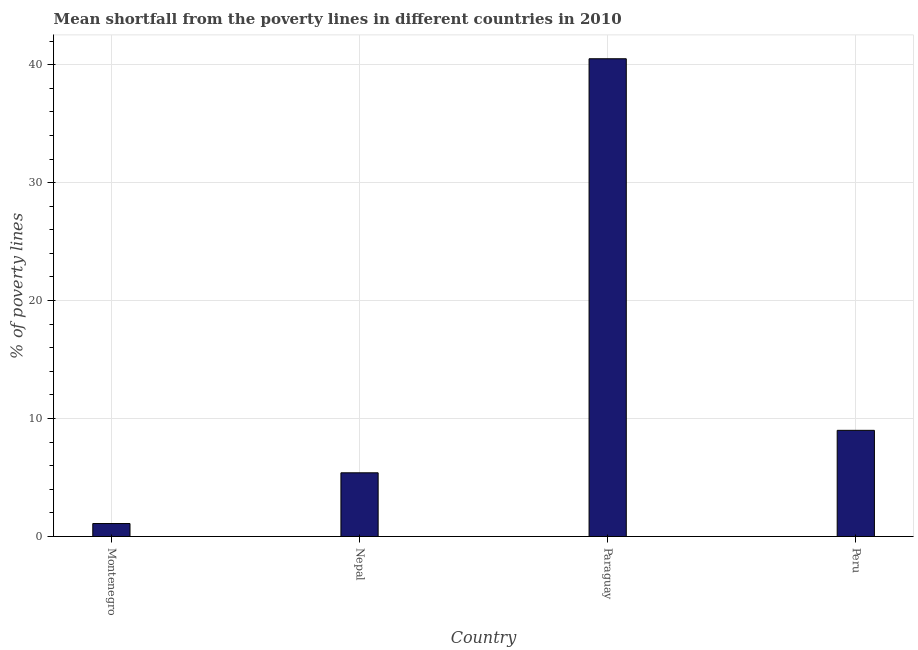Does the graph contain any zero values?
Your answer should be very brief. No. What is the title of the graph?
Make the answer very short. Mean shortfall from the poverty lines in different countries in 2010. What is the label or title of the X-axis?
Your response must be concise. Country. What is the label or title of the Y-axis?
Provide a short and direct response. % of poverty lines. Across all countries, what is the maximum poverty gap at national poverty lines?
Give a very brief answer. 40.5. In which country was the poverty gap at national poverty lines maximum?
Your answer should be very brief. Paraguay. In which country was the poverty gap at national poverty lines minimum?
Your answer should be compact. Montenegro. What is the sum of the poverty gap at national poverty lines?
Your answer should be very brief. 56. What is the difference between the poverty gap at national poverty lines in Paraguay and Peru?
Your answer should be very brief. 31.5. What is the average poverty gap at national poverty lines per country?
Offer a terse response. 14. What is the median poverty gap at national poverty lines?
Offer a very short reply. 7.2. What is the ratio of the poverty gap at national poverty lines in Paraguay to that in Peru?
Give a very brief answer. 4.5. Is the poverty gap at national poverty lines in Montenegro less than that in Paraguay?
Give a very brief answer. Yes. What is the difference between the highest and the second highest poverty gap at national poverty lines?
Ensure brevity in your answer.  31.5. What is the difference between the highest and the lowest poverty gap at national poverty lines?
Offer a terse response. 39.4. Are all the bars in the graph horizontal?
Offer a very short reply. No. What is the % of poverty lines in Paraguay?
Offer a terse response. 40.5. What is the % of poverty lines in Peru?
Offer a very short reply. 9. What is the difference between the % of poverty lines in Montenegro and Paraguay?
Your answer should be compact. -39.4. What is the difference between the % of poverty lines in Nepal and Paraguay?
Keep it short and to the point. -35.1. What is the difference between the % of poverty lines in Paraguay and Peru?
Your answer should be very brief. 31.5. What is the ratio of the % of poverty lines in Montenegro to that in Nepal?
Offer a very short reply. 0.2. What is the ratio of the % of poverty lines in Montenegro to that in Paraguay?
Make the answer very short. 0.03. What is the ratio of the % of poverty lines in Montenegro to that in Peru?
Ensure brevity in your answer.  0.12. What is the ratio of the % of poverty lines in Nepal to that in Paraguay?
Keep it short and to the point. 0.13. What is the ratio of the % of poverty lines in Nepal to that in Peru?
Offer a very short reply. 0.6. What is the ratio of the % of poverty lines in Paraguay to that in Peru?
Offer a very short reply. 4.5. 